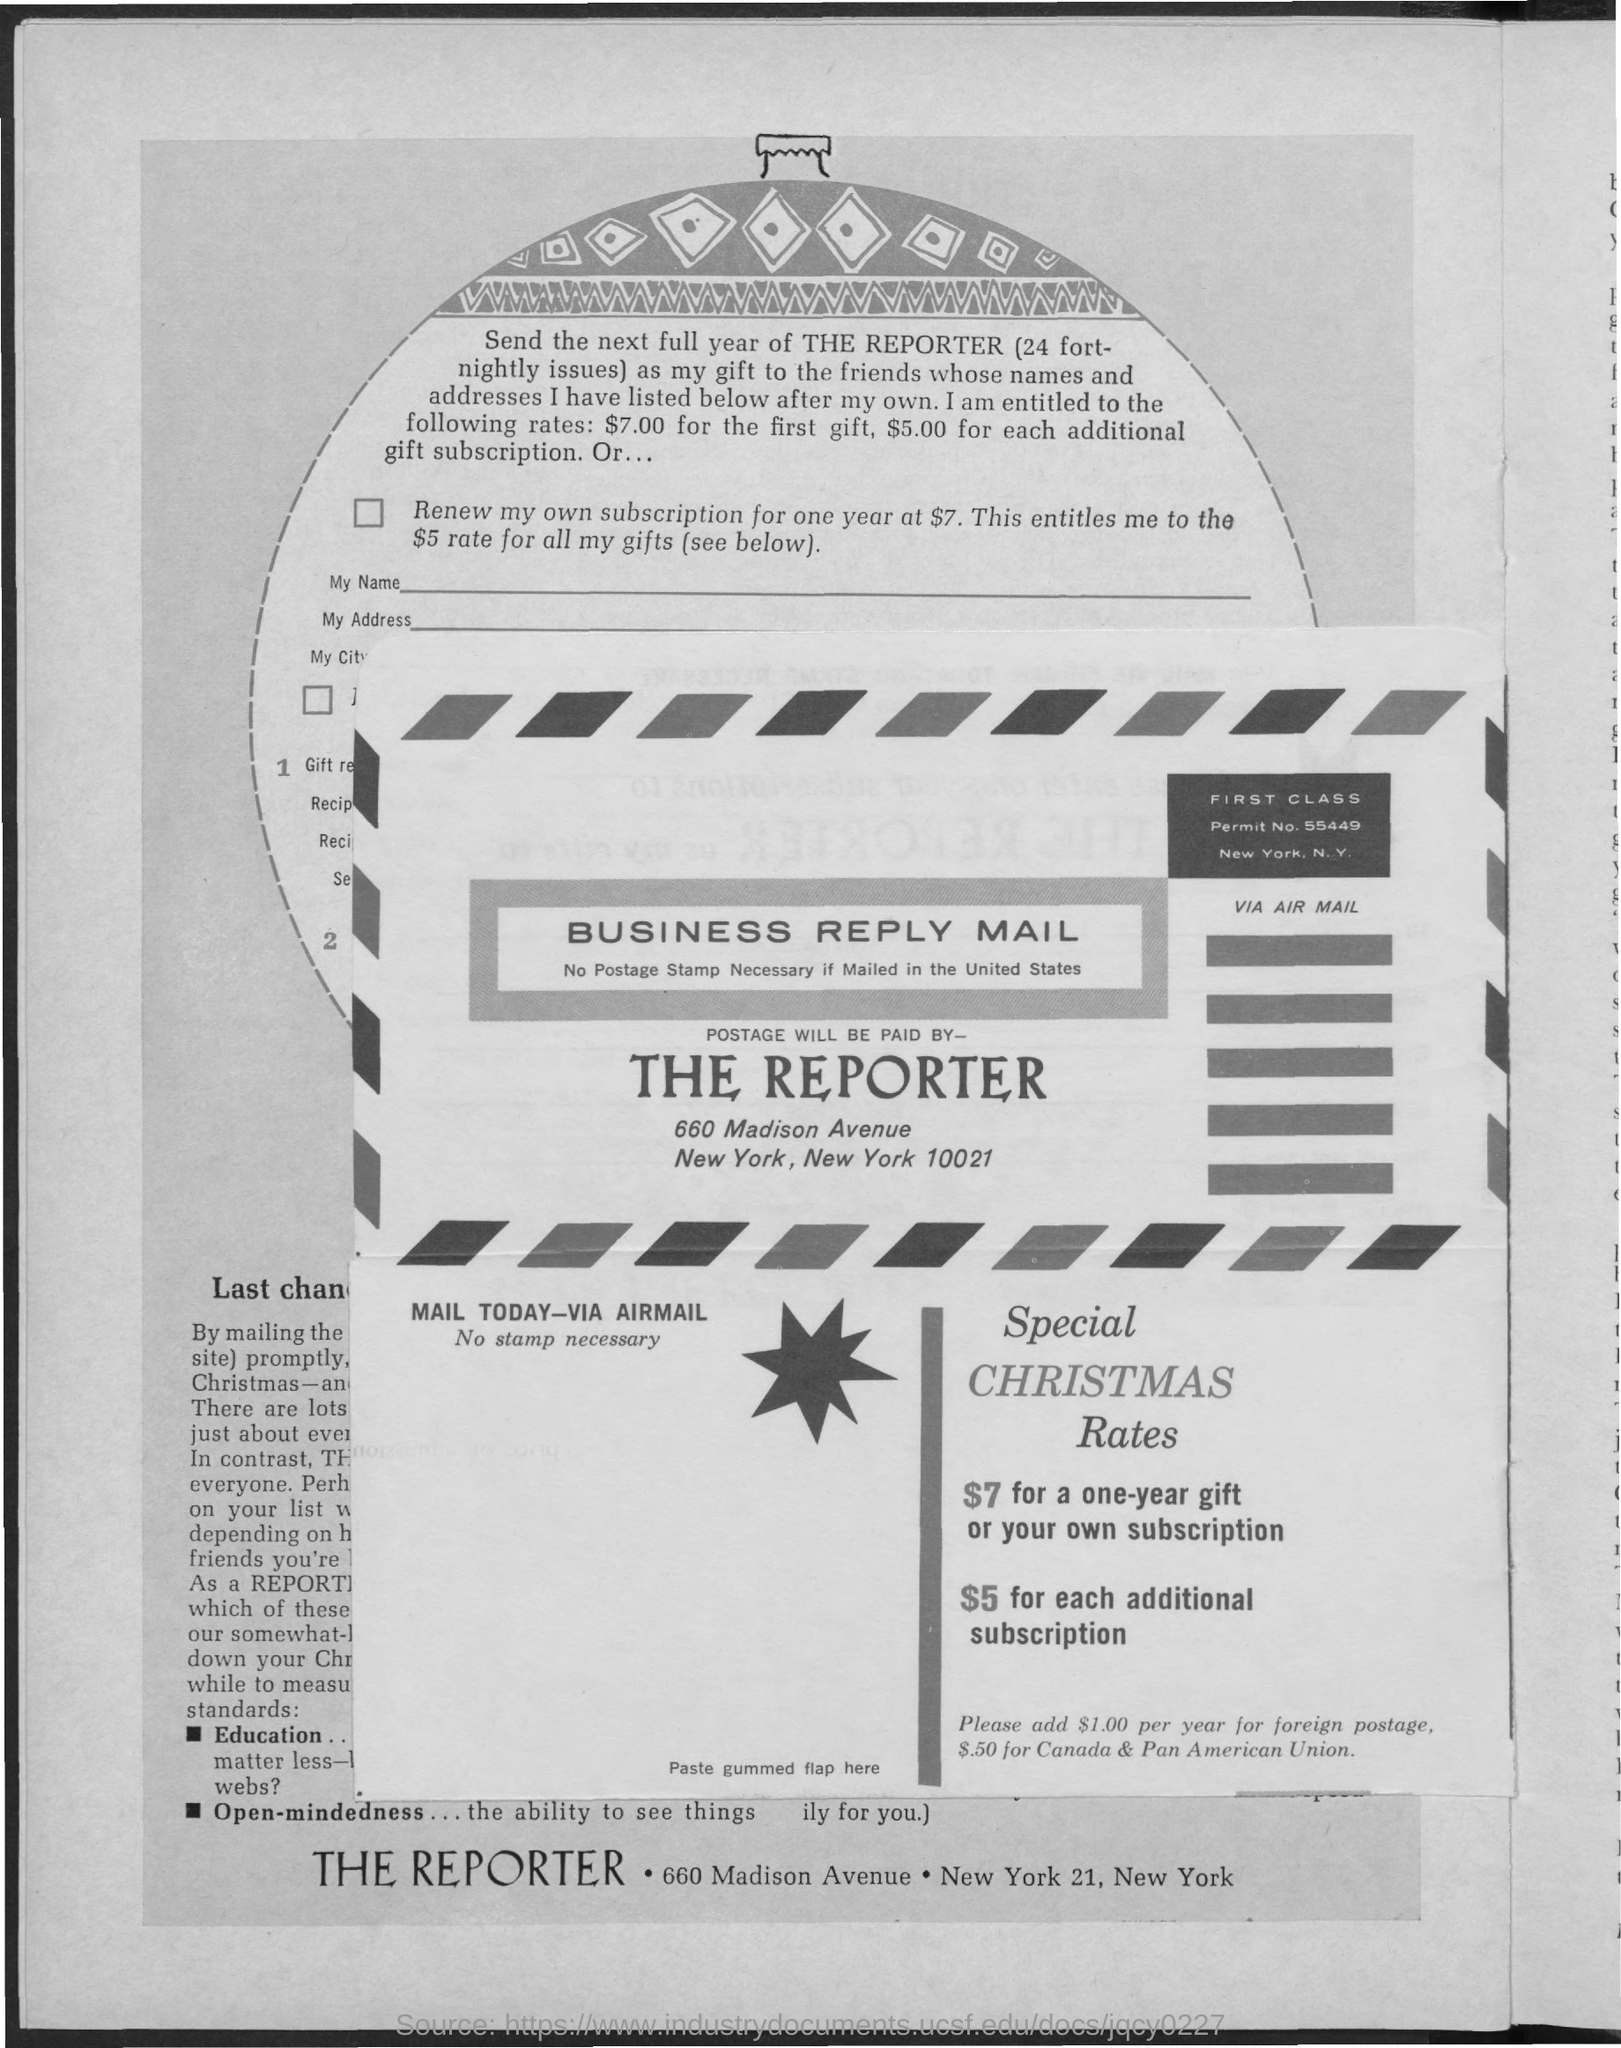Postage is paid by whom?
Offer a very short reply. THE REPORTER. What is the permit number?
Give a very brief answer. 55449. 